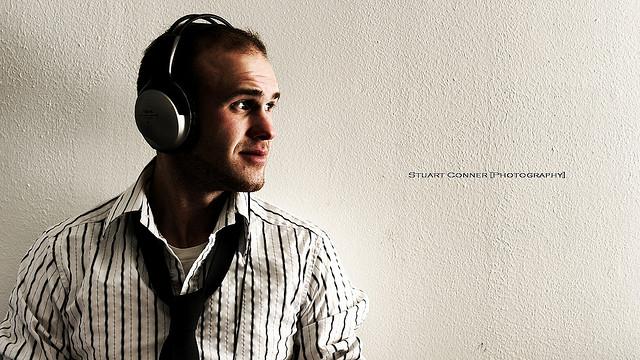Is this man wearing beats by dre?
Answer briefly. No. What pattern is the man's shirt?
Concise answer only. Striped. What is around the man's neck?
Concise answer only. Tie. 